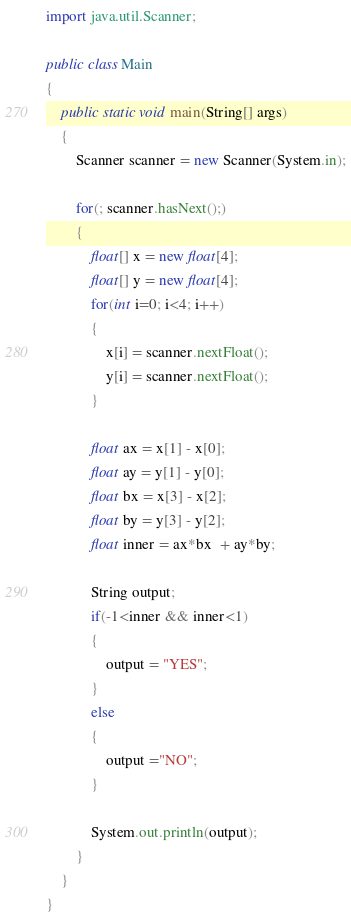<code> <loc_0><loc_0><loc_500><loc_500><_Java_>import java.util.Scanner;

public class Main
{
	public static void main(String[] args)
	{
		Scanner scanner = new Scanner(System.in);
		
		for(; scanner.hasNext();)
		{
			float[] x = new float[4];
			float[] y = new float[4];
			for(int i=0; i<4; i++)
			{
				x[i] = scanner.nextFloat();
				y[i] = scanner.nextFloat();
			}
			
			float ax = x[1] - x[0];
			float ay = y[1] - y[0];
			float bx = x[3] - x[2];
			float by = y[3] - y[2];
			float inner = ax*bx  + ay*by;
			
			String output;
			if(-1<inner && inner<1)
			{
				output = "YES";
			}
			else
			{
				output ="NO";
			}
			
			System.out.println(output);
		}
	}
}</code> 